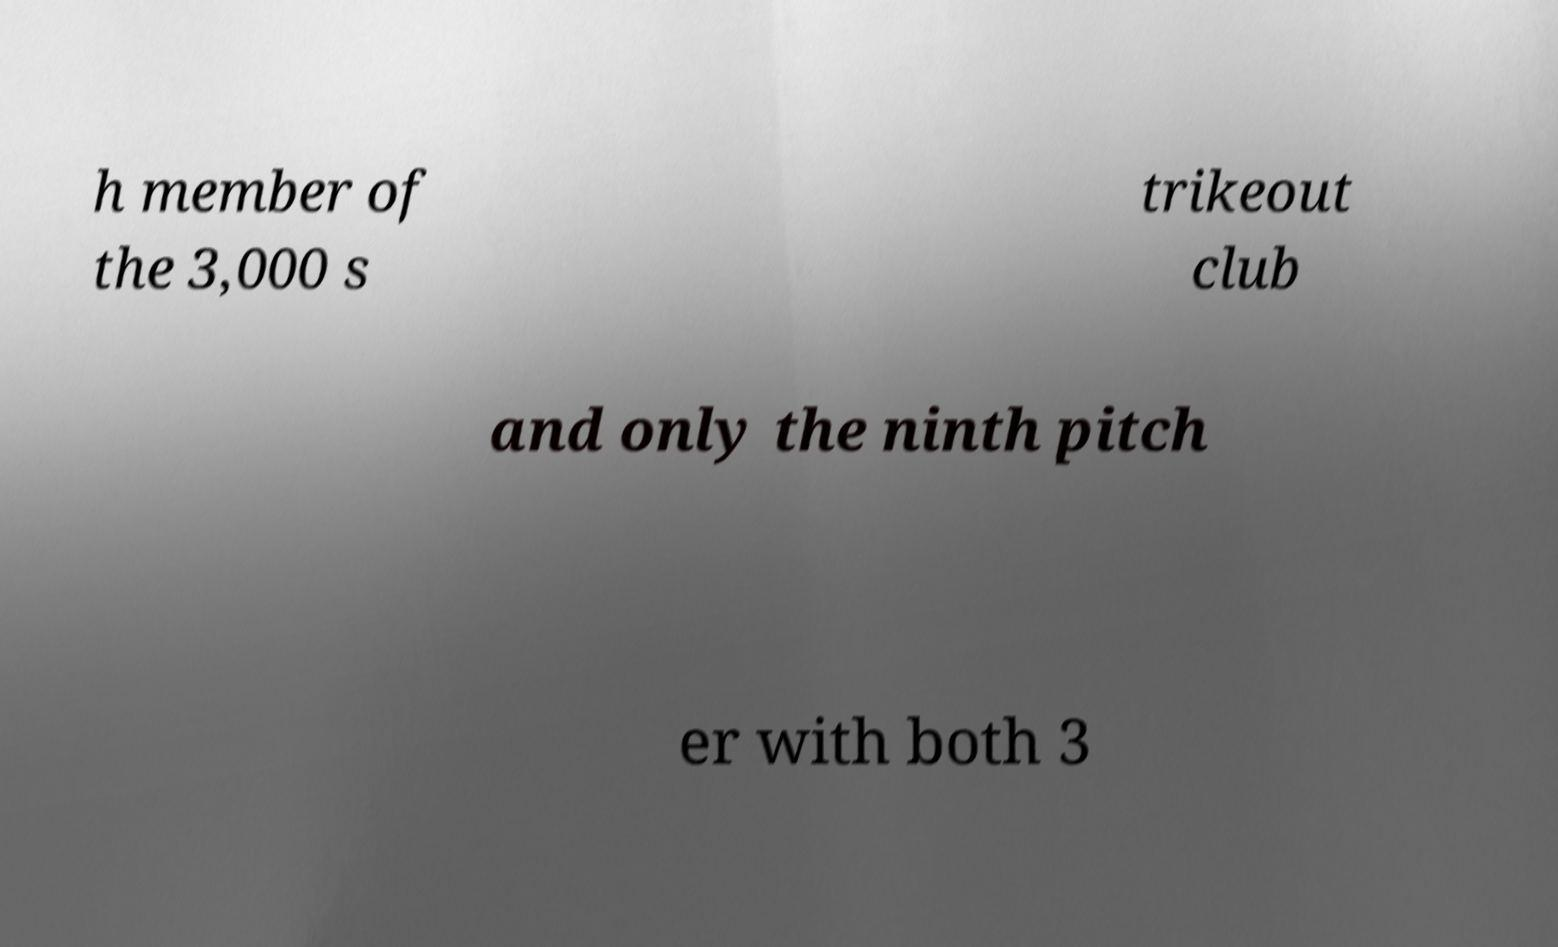Please identify and transcribe the text found in this image. h member of the 3,000 s trikeout club and only the ninth pitch er with both 3 